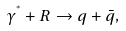<formula> <loc_0><loc_0><loc_500><loc_500>\gamma ^ { ^ { * } } + R \to q + \bar { q } ,</formula> 